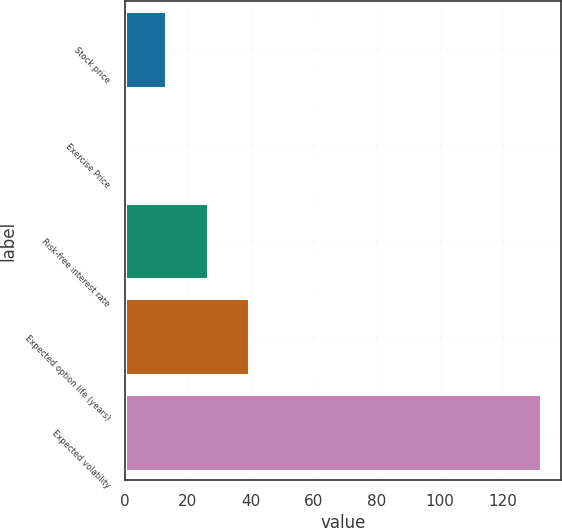<chart> <loc_0><loc_0><loc_500><loc_500><bar_chart><fcel>Stock price<fcel>Exercise Price<fcel>Risk-free interest rate<fcel>Expected option life (years)<fcel>Expected volatility<nl><fcel>13.2<fcel>0.01<fcel>26.39<fcel>39.58<fcel>131.9<nl></chart> 